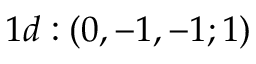Convert formula to latex. <formula><loc_0><loc_0><loc_500><loc_500>1 d \colon ( 0 , - 1 , - 1 ; 1 )</formula> 